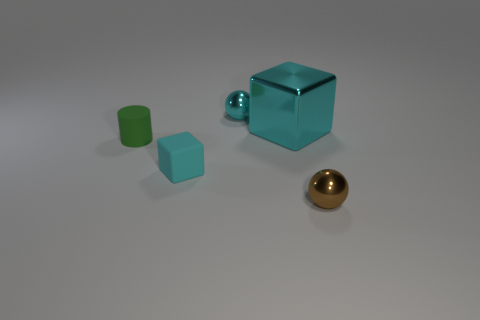There is a small sphere that is behind the tiny metallic ball right of the large cube; what is its material?
Provide a short and direct response. Metal. What size is the cyan thing that is on the right side of the small cyan ball?
Provide a succinct answer. Large. Does the tiny block have the same color as the cube right of the rubber block?
Ensure brevity in your answer.  Yes. Are there any large metallic spheres that have the same color as the small cylinder?
Give a very brief answer. No. Is the material of the tiny cyan cube the same as the big cyan cube behind the matte cylinder?
Give a very brief answer. No. How many small things are either shiny objects or yellow shiny cubes?
Your answer should be very brief. 2. What is the material of the big object that is the same color as the tiny cube?
Provide a short and direct response. Metal. Are there fewer brown spheres than spheres?
Offer a terse response. Yes. Is the size of the metallic object left of the big thing the same as the cyan cube that is in front of the small rubber cylinder?
Your answer should be very brief. Yes. How many gray things are either small matte things or large objects?
Ensure brevity in your answer.  0. 